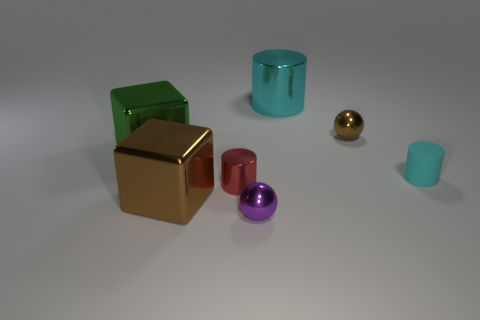Add 2 small purple objects. How many objects exist? 9 Subtract all blocks. How many objects are left? 5 Subtract all large brown metal cubes. Subtract all small brown things. How many objects are left? 5 Add 7 small metallic cylinders. How many small metallic cylinders are left? 8 Add 7 large green cubes. How many large green cubes exist? 8 Subtract 1 red cylinders. How many objects are left? 6 